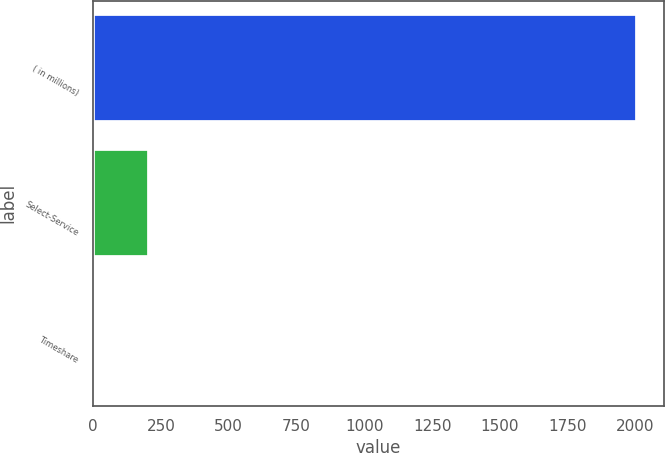Convert chart to OTSL. <chart><loc_0><loc_0><loc_500><loc_500><bar_chart><fcel>( in millions)<fcel>Select-Service<fcel>Timeshare<nl><fcel>2004<fcel>206.7<fcel>7<nl></chart> 